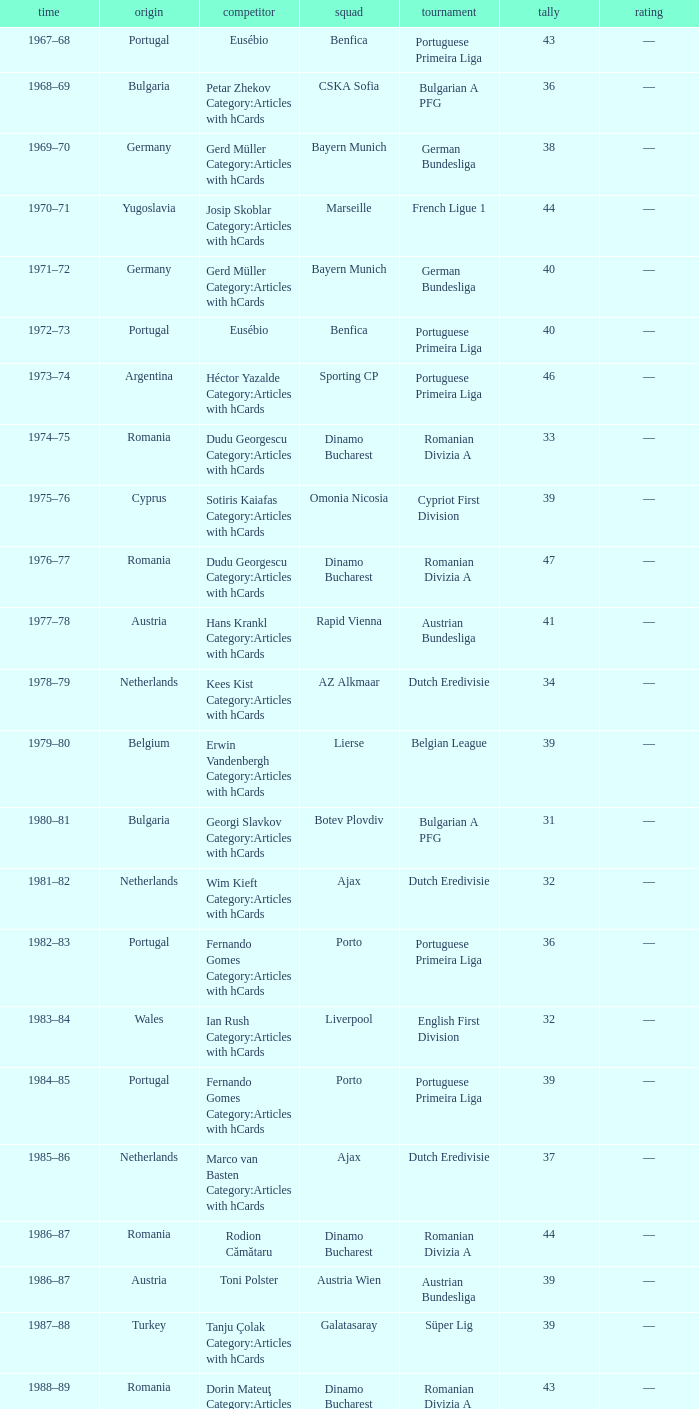Which player was in the Omonia Nicosia club? Sotiris Kaiafas Category:Articles with hCards. 